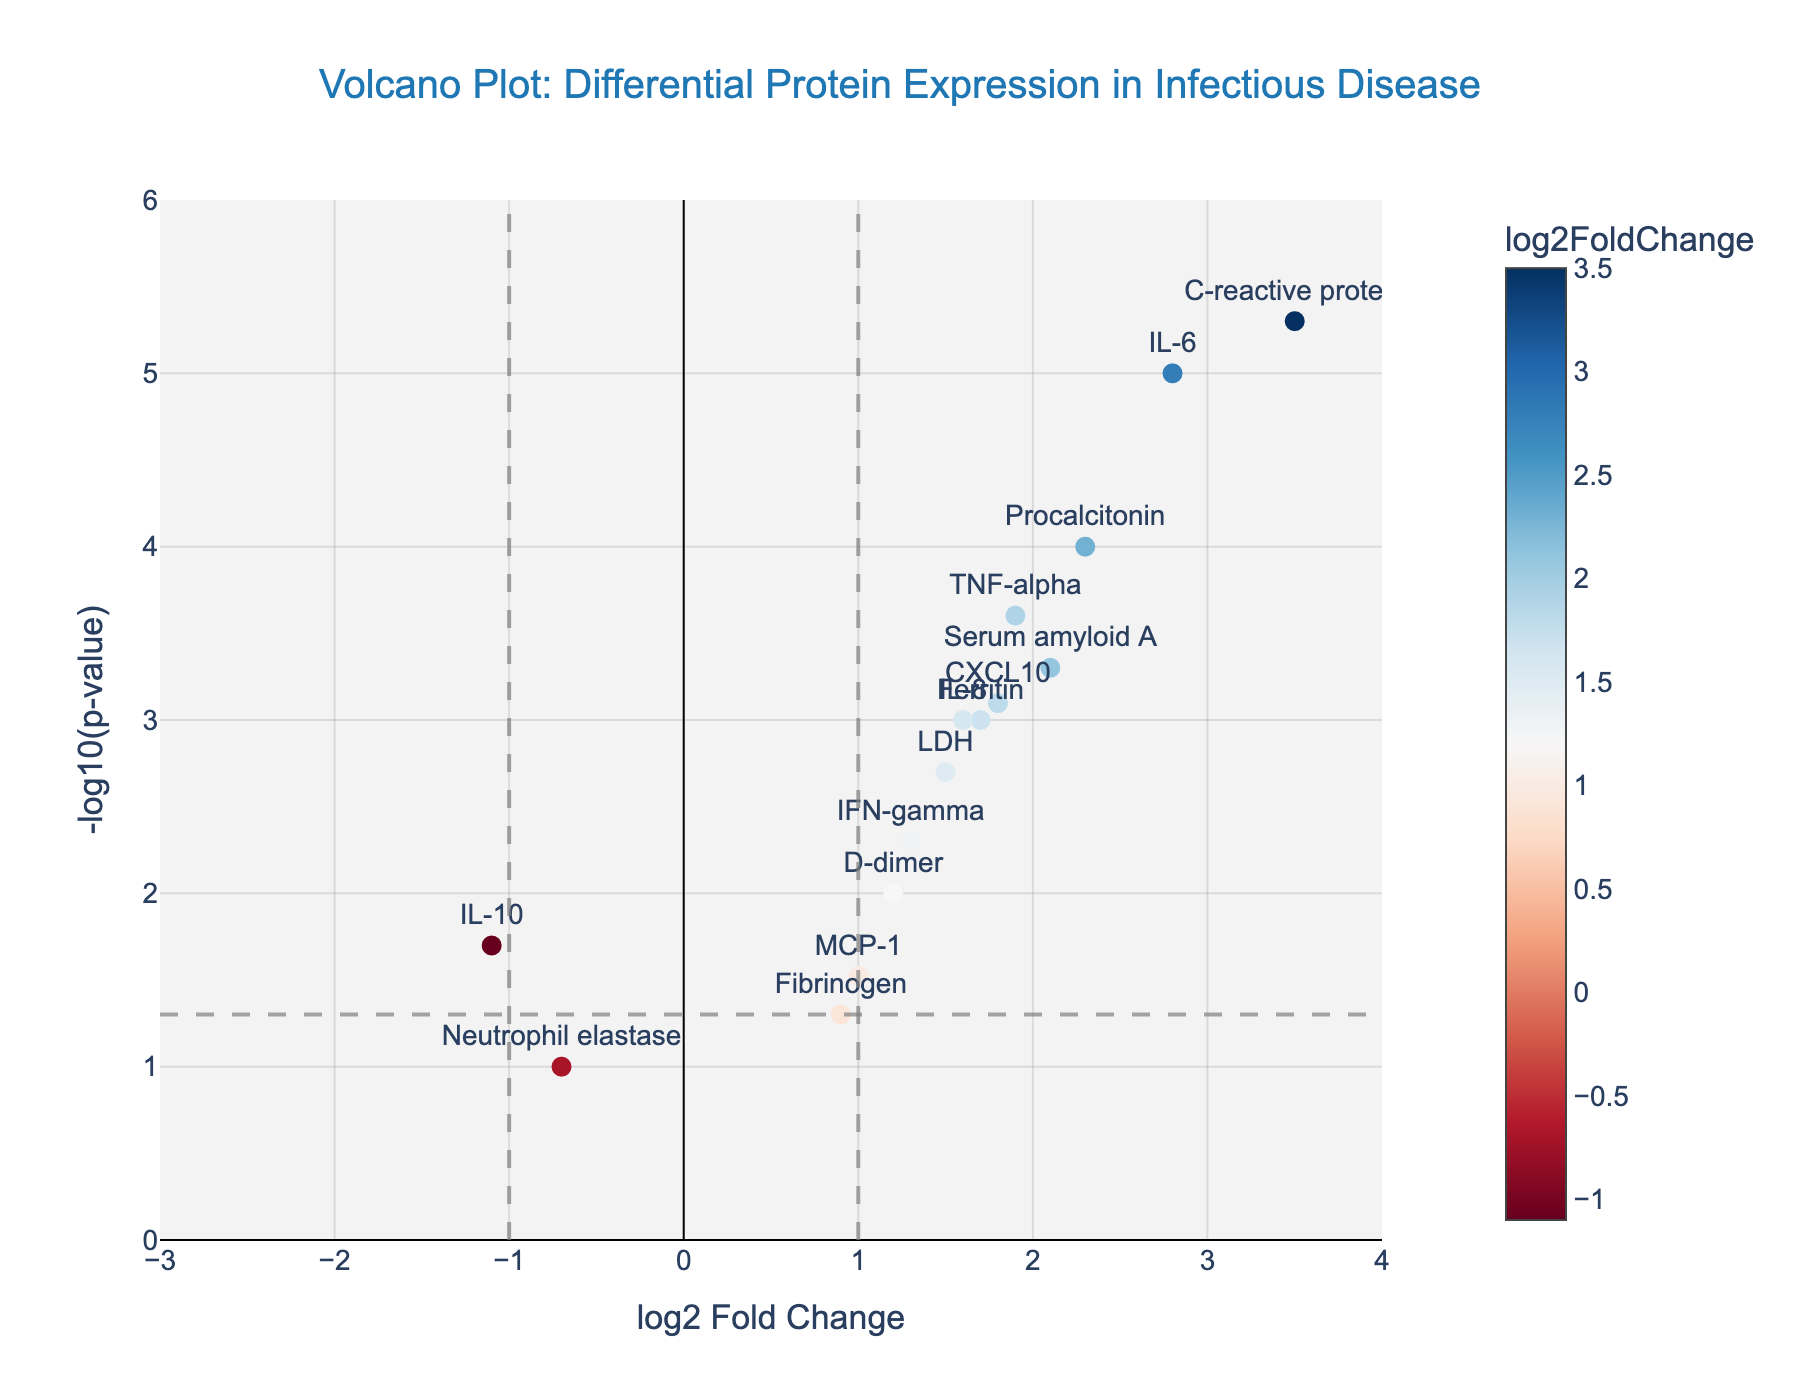Which protein has the highest log2FoldChange? By looking at the x-axis (log2FoldChange), identify the protein with the highest positive value. The protein "C-reactive protein" is plotted furthest to the right on the x-axis.
Answer: C-reactive protein How many proteins have a -log10(p-value) greater than 5? By looking at the y-axis (-log10(p-value)), count the data points above 5. There are two proteins: "IL-6" and "C-reactive protein".
Answer: 2 Which protein has the lowest log2FoldChange? By finding the data point with the lowest x-axis value (log2FoldChange). "Neutrophil elastase" is furthest to the left.
Answer: Neutrophil elastase Which proteins are significantly upregulated (log2FoldChange > 1 and p-value < 0.05)? Look at data points to the right of the vertical line at 1 and above the horizontal line at -log10(0.05). Proteins meeting these criteria are "IL-6", "TNF-alpha", "C-reactive protein", "Procalcitonin", "Serum amyloid A", and "CXCL10".
Answer: IL-6, TNF-alpha, C-reactive protein, Procalcitonin, Serum amyloid A, CXCL10 Which protein exhibits the most significant change (smallest p-value)? Identify the highest point on the y-axis (-log10(p-value)) as this reflects the smallest p-value. The "C-reactive protein" has the highest value.
Answer: C-reactive protein What is the log2FoldChange for the protein "IL-8"? Locate "IL-8" on the plot and check its x-axis value (log2FoldChange). IL-8 has a log2FoldChange of 1.6.
Answer: 1.6 How many proteins have a log2FoldChange between -1 and 1? Count the data points between the vertical lines at -1 and 1 on the x-axis. There are four proteins: "Fibrinogen", "Neutrophil elastase", "IL-10", and "MCP-1".
Answer: 4 Which protein has the highest p-value? Identify the protein with the lowest y-axis value, which corresponds to the highest p-value (-log10(p-value)). The lowest point on the plot is "Neutrophil elastase".
Answer: Neutrophil elastase 